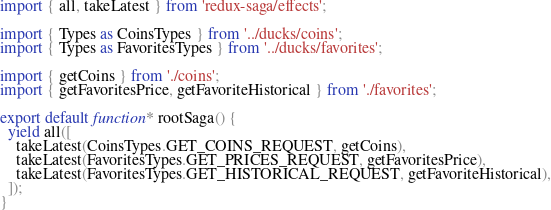<code> <loc_0><loc_0><loc_500><loc_500><_JavaScript_>import { all, takeLatest } from 'redux-saga/effects';

import { Types as CoinsTypes } from '../ducks/coins';
import { Types as FavoritesTypes } from '../ducks/favorites';

import { getCoins } from './coins';
import { getFavoritesPrice, getFavoriteHistorical } from './favorites';

export default function* rootSaga() {
  yield all([
    takeLatest(CoinsTypes.GET_COINS_REQUEST, getCoins),
    takeLatest(FavoritesTypes.GET_PRICES_REQUEST, getFavoritesPrice),
    takeLatest(FavoritesTypes.GET_HISTORICAL_REQUEST, getFavoriteHistorical),
  ]);
}
</code> 